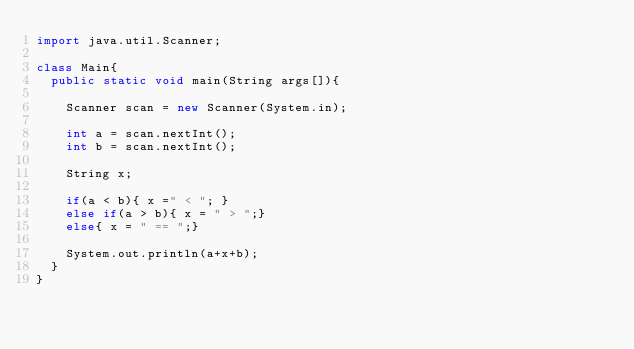<code> <loc_0><loc_0><loc_500><loc_500><_Java_>import java.util.Scanner;

class Main{
  public static void main(String args[]){

    Scanner scan = new Scanner(System.in);

    int a = scan.nextInt();
    int b = scan.nextInt();

    String x;
    
    if(a < b){ x =" < "; }
    else if(a > b){ x = " > ";}
    else{ x = " == ";}

    System.out.println(a+x+b);
  }
}</code> 